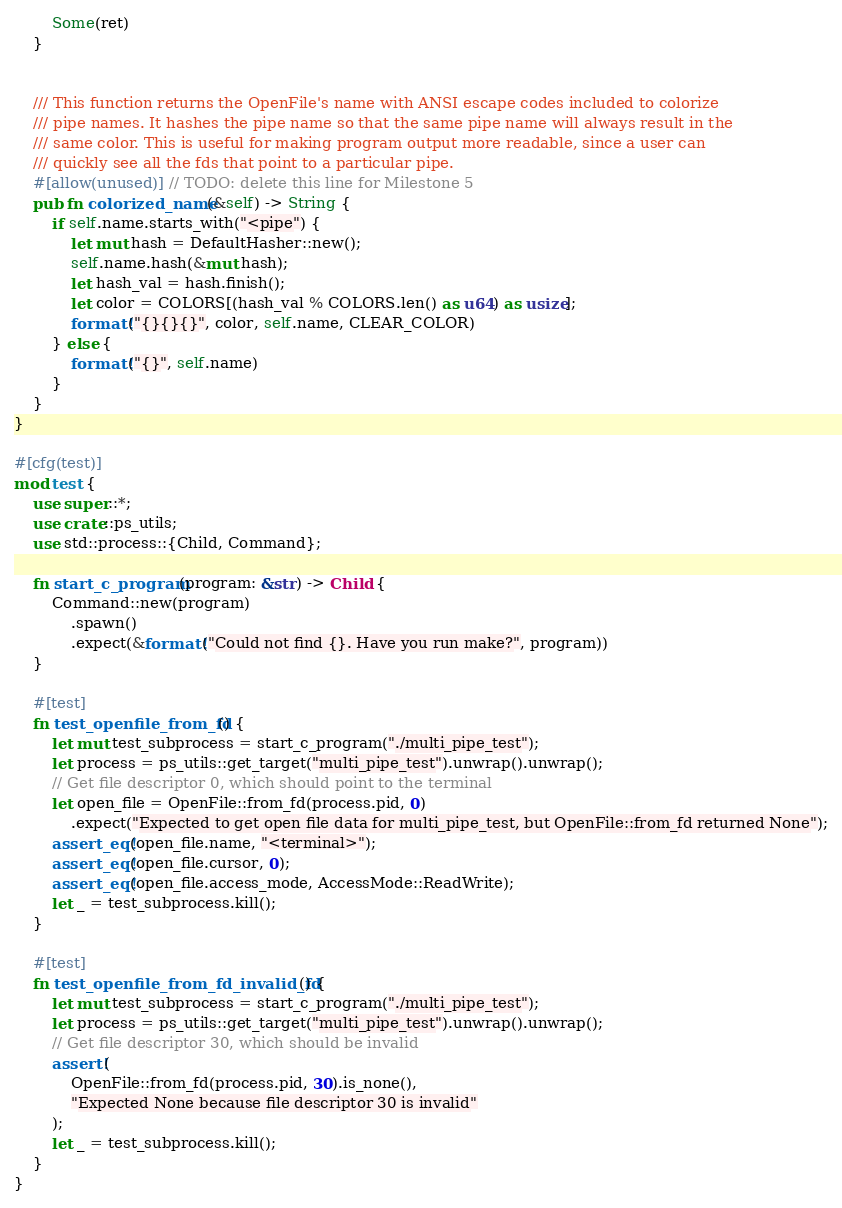<code> <loc_0><loc_0><loc_500><loc_500><_Rust_>        Some(ret)
    }


    /// This function returns the OpenFile's name with ANSI escape codes included to colorize
    /// pipe names. It hashes the pipe name so that the same pipe name will always result in the
    /// same color. This is useful for making program output more readable, since a user can
    /// quickly see all the fds that point to a particular pipe.
    #[allow(unused)] // TODO: delete this line for Milestone 5
    pub fn colorized_name(&self) -> String {
        if self.name.starts_with("<pipe") {
            let mut hash = DefaultHasher::new();
            self.name.hash(&mut hash);
            let hash_val = hash.finish();
            let color = COLORS[(hash_val % COLORS.len() as u64) as usize];
            format!("{}{}{}", color, self.name, CLEAR_COLOR)
        } else {
            format!("{}", self.name)
        }
    }
}

#[cfg(test)]
mod test {
    use super::*;
    use crate::ps_utils;
    use std::process::{Child, Command};

    fn start_c_program(program: &str) -> Child {
        Command::new(program)
            .spawn()
            .expect(&format!("Could not find {}. Have you run make?", program))
    }

    #[test]
    fn test_openfile_from_fd() {
        let mut test_subprocess = start_c_program("./multi_pipe_test");
        let process = ps_utils::get_target("multi_pipe_test").unwrap().unwrap();
        // Get file descriptor 0, which should point to the terminal
        let open_file = OpenFile::from_fd(process.pid, 0)
            .expect("Expected to get open file data for multi_pipe_test, but OpenFile::from_fd returned None");
        assert_eq!(open_file.name, "<terminal>");
        assert_eq!(open_file.cursor, 0);
        assert_eq!(open_file.access_mode, AccessMode::ReadWrite);
        let _ = test_subprocess.kill();
    }

    #[test]
    fn test_openfile_from_fd_invalid_fd() {
        let mut test_subprocess = start_c_program("./multi_pipe_test");
        let process = ps_utils::get_target("multi_pipe_test").unwrap().unwrap();
        // Get file descriptor 30, which should be invalid
        assert!(
            OpenFile::from_fd(process.pid, 30).is_none(),
            "Expected None because file descriptor 30 is invalid"
        );
        let _ = test_subprocess.kill();
    }
}
</code> 